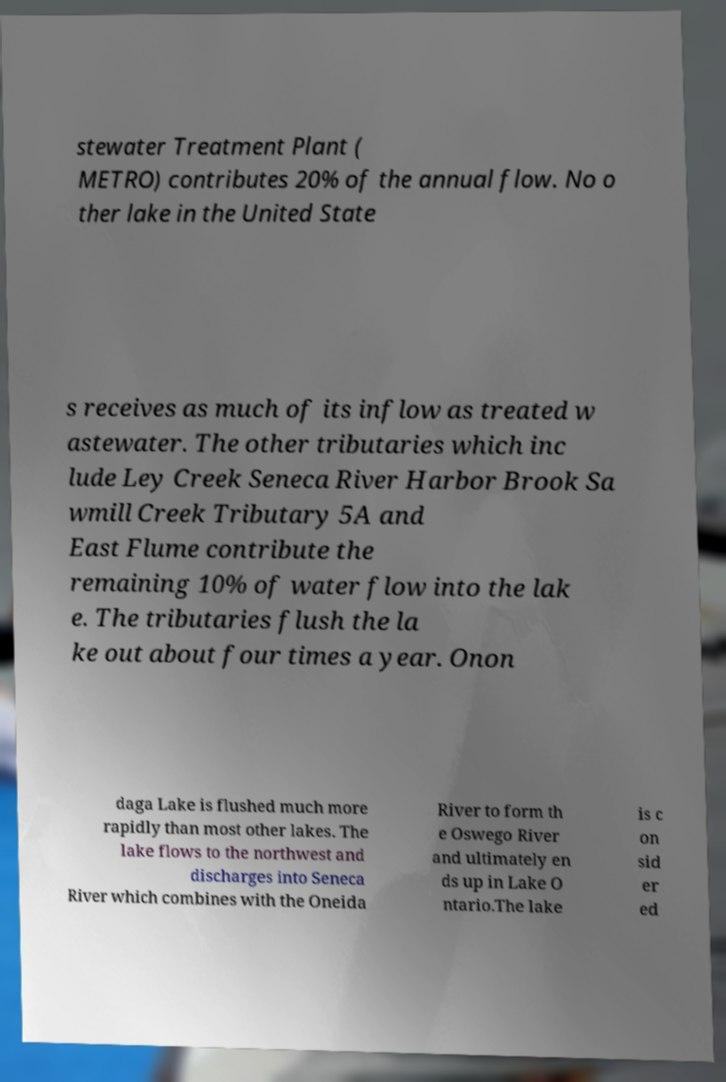Please identify and transcribe the text found in this image. stewater Treatment Plant ( METRO) contributes 20% of the annual flow. No o ther lake in the United State s receives as much of its inflow as treated w astewater. The other tributaries which inc lude Ley Creek Seneca River Harbor Brook Sa wmill Creek Tributary 5A and East Flume contribute the remaining 10% of water flow into the lak e. The tributaries flush the la ke out about four times a year. Onon daga Lake is flushed much more rapidly than most other lakes. The lake flows to the northwest and discharges into Seneca River which combines with the Oneida River to form th e Oswego River and ultimately en ds up in Lake O ntario.The lake is c on sid er ed 